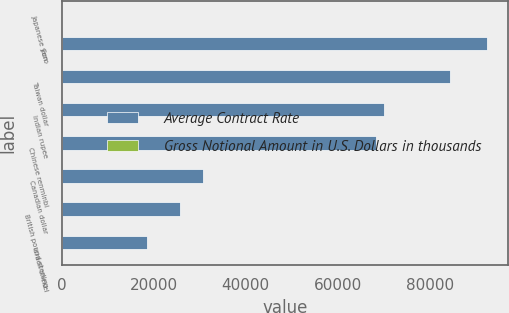<chart> <loc_0><loc_0><loc_500><loc_500><stacked_bar_chart><ecel><fcel>Japanese yen<fcel>Euro<fcel>Taiwan dollar<fcel>Indian rupee<fcel>Chinese renminbi<fcel>Canadian dollar<fcel>British pound sterling<fcel>Israeli shekel<nl><fcel>Average Contract Rate<fcel>96.33<fcel>92351<fcel>84458<fcel>70030<fcel>68208<fcel>30819<fcel>25638<fcel>18615<nl><fcel>Gross Notional Amount in U.S. Dollars in thousands<fcel>96.33<fcel>0.75<fcel>29.34<fcel>62.21<fcel>6.25<fcel>1.03<fcel>0.63<fcel>3.56<nl></chart> 